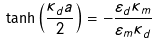Convert formula to latex. <formula><loc_0><loc_0><loc_500><loc_500>\tanh { \left ( \frac { \kappa _ { d } a } { 2 } \right ) } = - \frac { \varepsilon _ { d } \kappa _ { m } } { \varepsilon _ { m } \kappa _ { d } }</formula> 